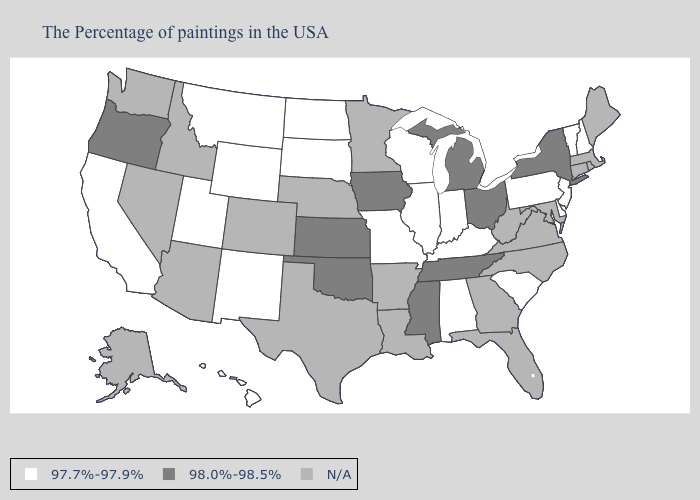Among the states that border Delaware , which have the lowest value?
Be succinct. New Jersey, Pennsylvania. What is the highest value in the MidWest ?
Be succinct. 98.0%-98.5%. Name the states that have a value in the range 98.0%-98.5%?
Write a very short answer. New York, Ohio, Michigan, Tennessee, Mississippi, Iowa, Kansas, Oklahoma, Oregon. What is the value of North Dakota?
Quick response, please. 97.7%-97.9%. Does New York have the highest value in the USA?
Be succinct. Yes. What is the value of Nebraska?
Answer briefly. N/A. Does Tennessee have the highest value in the USA?
Keep it brief. Yes. What is the value of Kentucky?
Quick response, please. 97.7%-97.9%. What is the lowest value in the South?
Keep it brief. 97.7%-97.9%. Does Utah have the highest value in the West?
Write a very short answer. No. Name the states that have a value in the range N/A?
Be succinct. Maine, Massachusetts, Rhode Island, Connecticut, Maryland, Virginia, North Carolina, West Virginia, Florida, Georgia, Louisiana, Arkansas, Minnesota, Nebraska, Texas, Colorado, Arizona, Idaho, Nevada, Washington, Alaska. Is the legend a continuous bar?
Answer briefly. No. Does Alabama have the highest value in the South?
Write a very short answer. No. Name the states that have a value in the range 97.7%-97.9%?
Be succinct. New Hampshire, Vermont, New Jersey, Delaware, Pennsylvania, South Carolina, Kentucky, Indiana, Alabama, Wisconsin, Illinois, Missouri, South Dakota, North Dakota, Wyoming, New Mexico, Utah, Montana, California, Hawaii. 